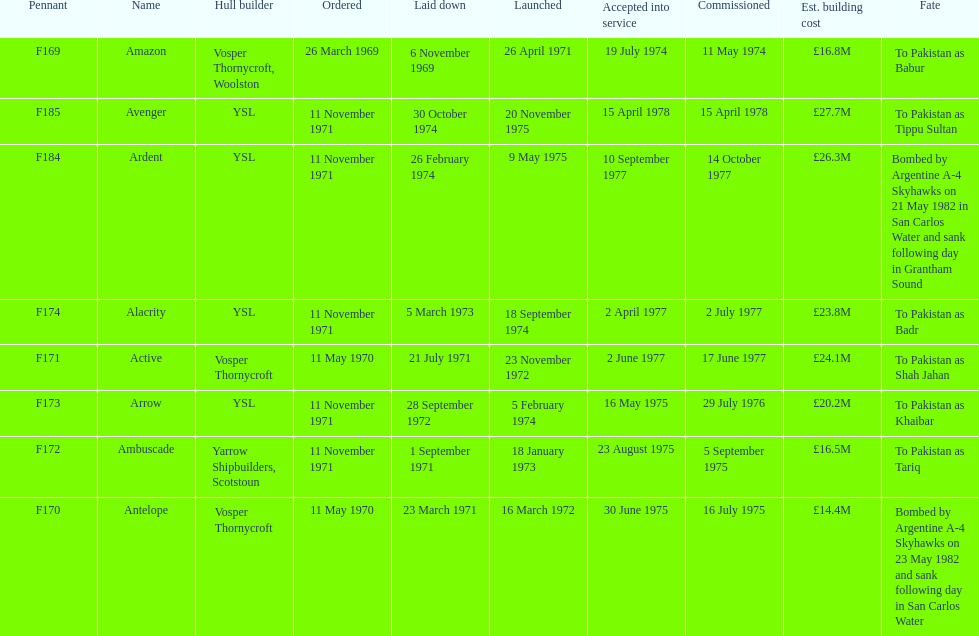The arrow was ordered on november 11, 1971. what was the previous ship? Ambuscade. 